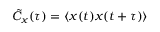<formula> <loc_0><loc_0><loc_500><loc_500>\tilde { C } _ { x } ( \tau ) = \langle x ( t ) x ( t + \tau ) \rangle</formula> 